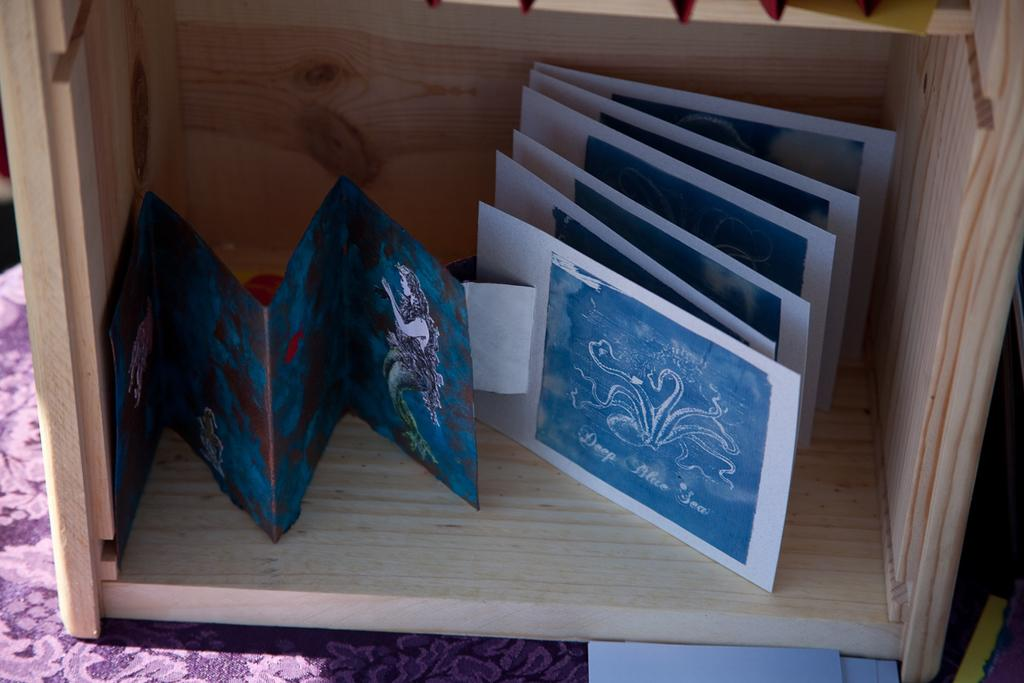What type of object is in the picture made of wood? There is a wooden box in the picture. What can be seen on the papers in the picture? There are images on the papers in the picture. What is covering the table in the picture? There is a cloth on the table in the picture. Where is the faucet located in the picture? There is no faucet present in the picture. How many clocks are visible in the picture? There are no clocks visible in the picture. 